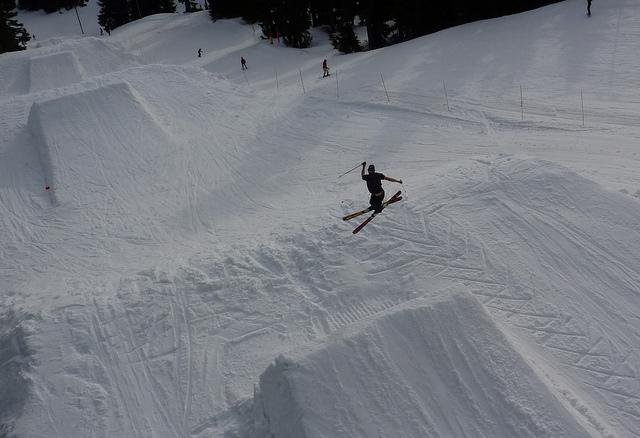Is it cold?
Keep it brief. Yes. Is this an Olympic sport?
Keep it brief. Yes. What is this person doing?
Write a very short answer. Skiing. 